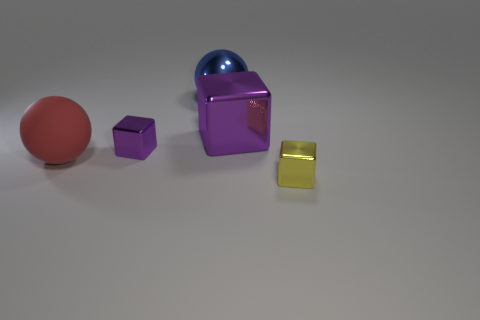What color is the big matte object that is the same shape as the blue metallic thing?
Make the answer very short. Red. There is a metal object that is the same color as the big cube; what shape is it?
Keep it short and to the point. Cube. There is a metallic object in front of the tiny object left of the small yellow metallic object; what number of objects are left of it?
Your answer should be compact. 4. What size is the purple shiny object behind the tiny thing behind the yellow metallic block?
Offer a very short reply. Large. There is a yellow thing that is the same material as the big cube; what is its size?
Your answer should be very brief. Small. What shape is the metallic object that is both in front of the big purple shiny object and left of the yellow object?
Provide a succinct answer. Cube. Are there the same number of rubber balls that are right of the big blue metal ball and tiny metallic objects?
Keep it short and to the point. No. How many objects are large blue matte things or large blue objects behind the large purple metal cube?
Ensure brevity in your answer.  1. Is there another blue metal object that has the same shape as the big blue shiny object?
Give a very brief answer. No. Is the number of rubber balls that are in front of the rubber sphere the same as the number of large blue things that are behind the blue shiny sphere?
Provide a succinct answer. Yes. 